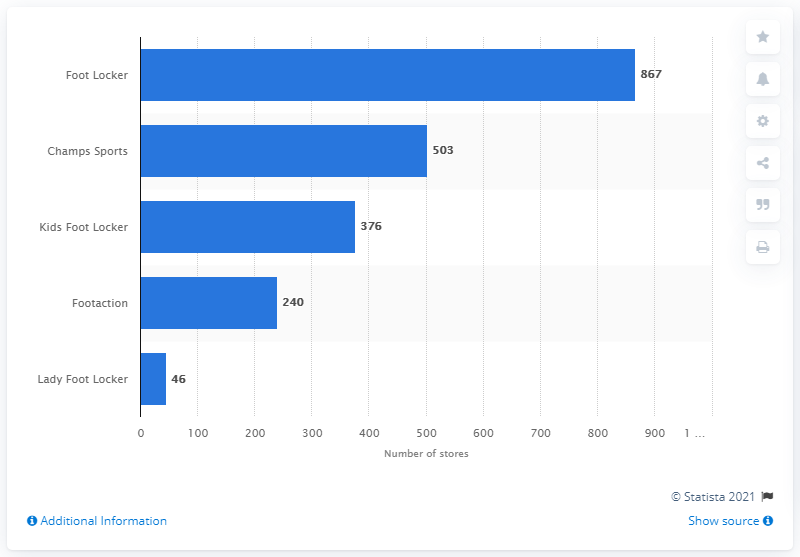Mention a couple of crucial points in this snapshot. As of February 1, 2020, there were 46 Lady Foot Locker stores in operation. 